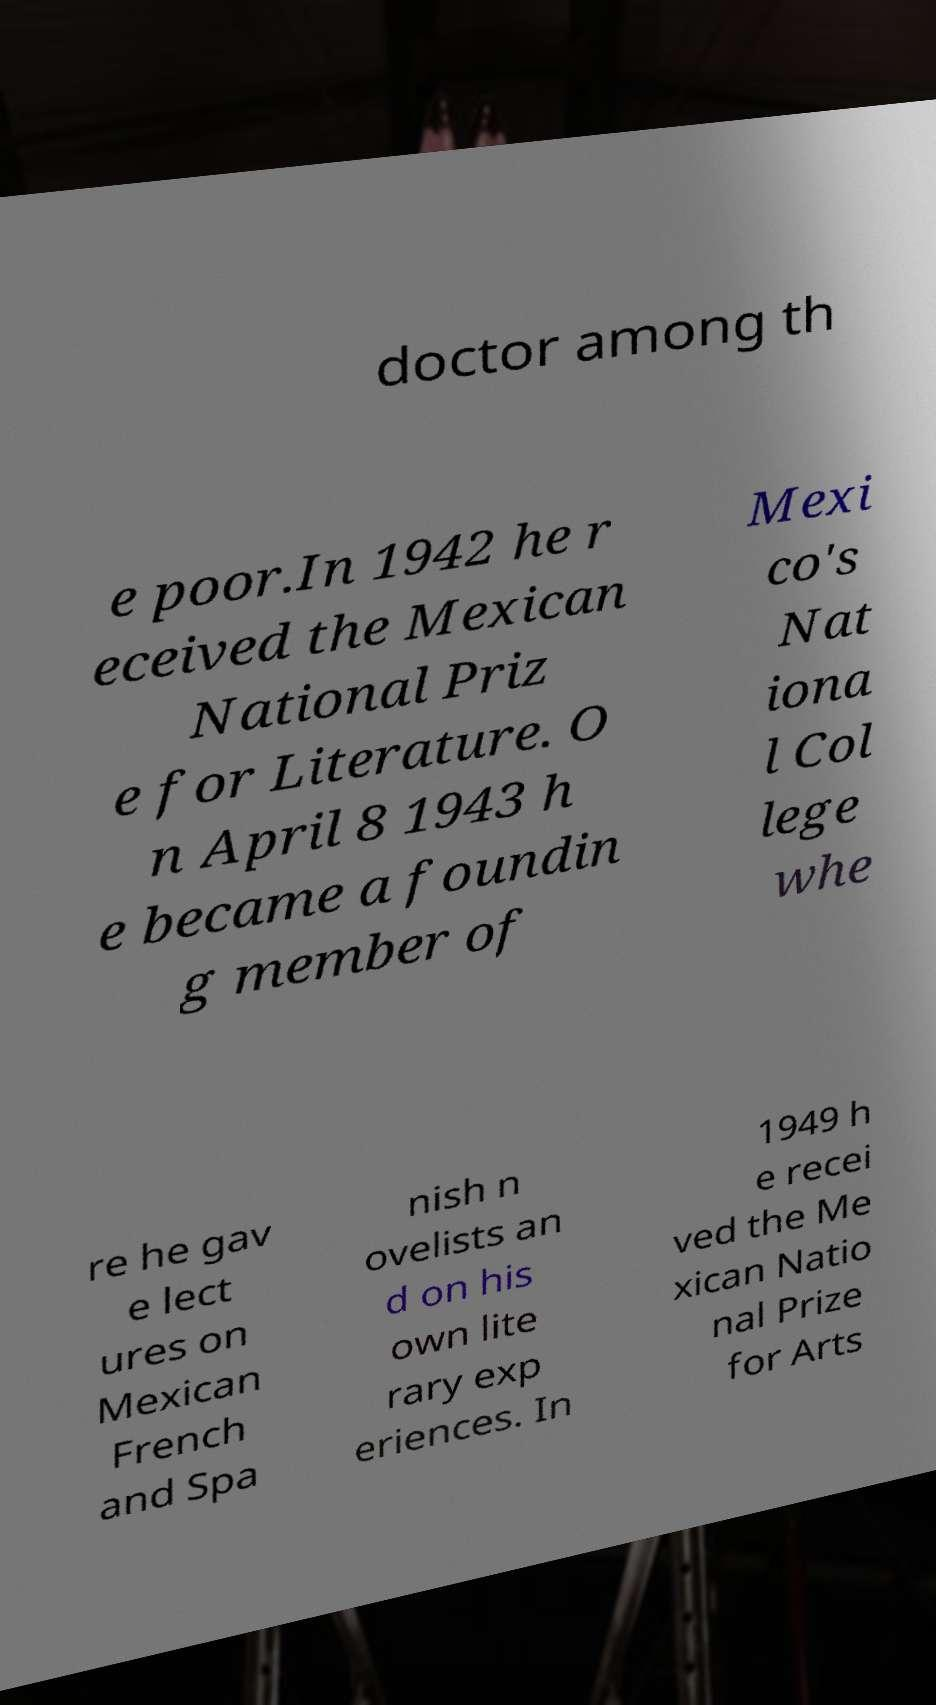Can you read and provide the text displayed in the image?This photo seems to have some interesting text. Can you extract and type it out for me? doctor among th e poor.In 1942 he r eceived the Mexican National Priz e for Literature. O n April 8 1943 h e became a foundin g member of Mexi co's Nat iona l Col lege whe re he gav e lect ures on Mexican French and Spa nish n ovelists an d on his own lite rary exp eriences. In 1949 h e recei ved the Me xican Natio nal Prize for Arts 